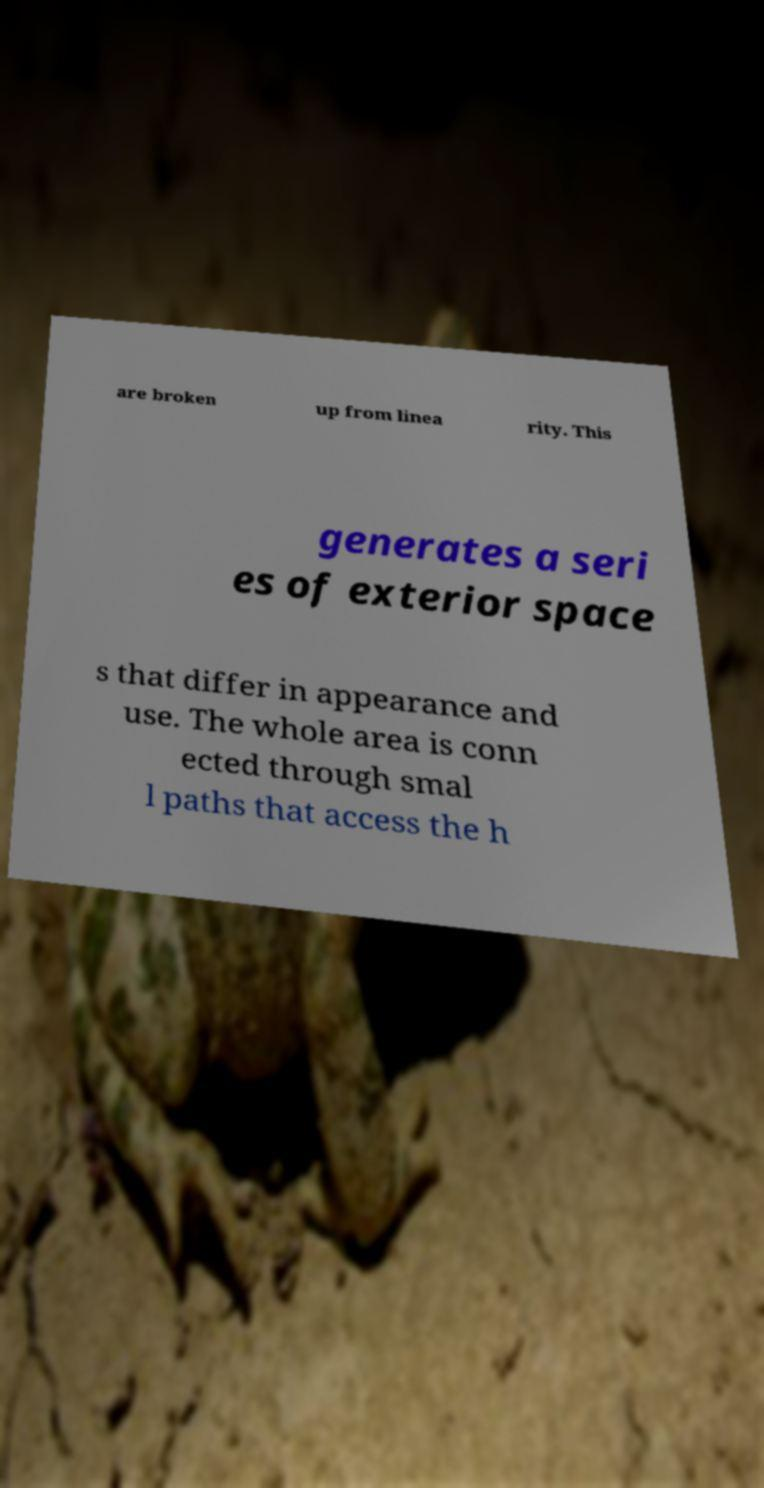Can you read and provide the text displayed in the image?This photo seems to have some interesting text. Can you extract and type it out for me? are broken up from linea rity. This generates a seri es of exterior space s that differ in appearance and use. The whole area is conn ected through smal l paths that access the h 